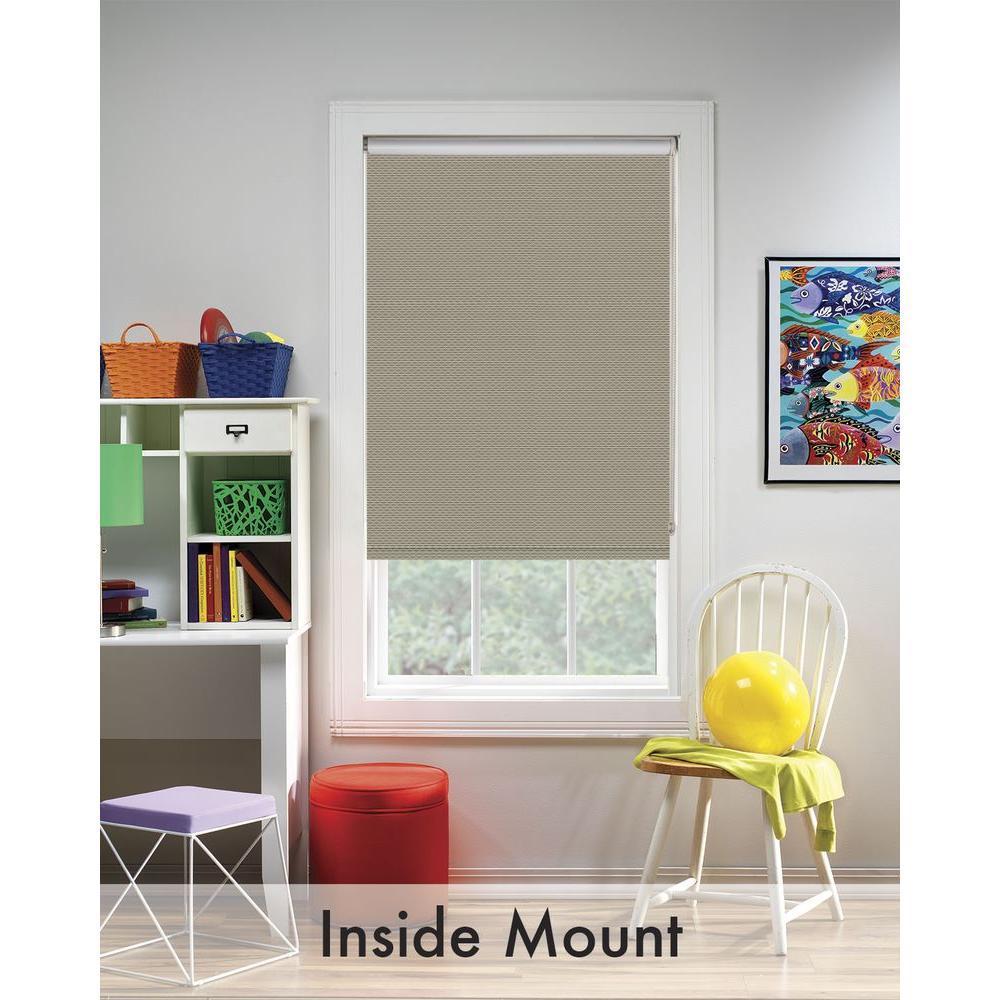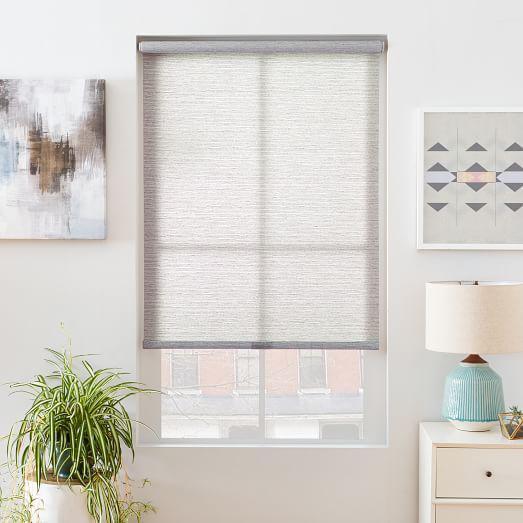The first image is the image on the left, the second image is the image on the right. Examine the images to the left and right. Is the description "There are exactly two window shades." accurate? Answer yes or no. Yes. 